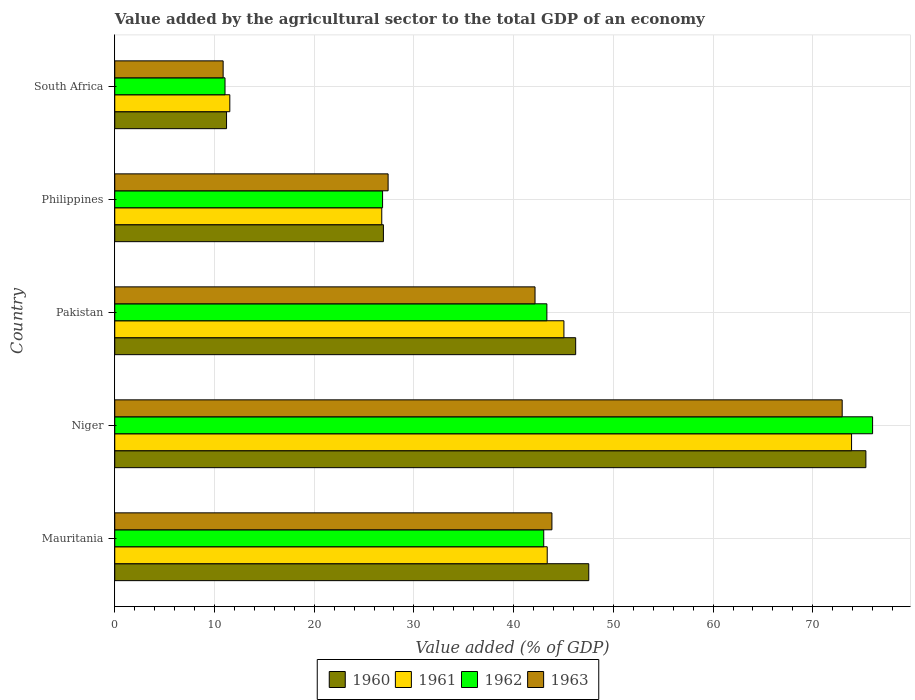How many groups of bars are there?
Keep it short and to the point. 5. Are the number of bars per tick equal to the number of legend labels?
Make the answer very short. Yes. Are the number of bars on each tick of the Y-axis equal?
Keep it short and to the point. Yes. How many bars are there on the 5th tick from the top?
Your response must be concise. 4. What is the label of the 1st group of bars from the top?
Your answer should be very brief. South Africa. What is the value added by the agricultural sector to the total GDP in 1963 in Niger?
Give a very brief answer. 72.95. Across all countries, what is the maximum value added by the agricultural sector to the total GDP in 1962?
Your response must be concise. 76. Across all countries, what is the minimum value added by the agricultural sector to the total GDP in 1963?
Your response must be concise. 10.87. In which country was the value added by the agricultural sector to the total GDP in 1962 maximum?
Offer a very short reply. Niger. In which country was the value added by the agricultural sector to the total GDP in 1961 minimum?
Provide a short and direct response. South Africa. What is the total value added by the agricultural sector to the total GDP in 1961 in the graph?
Offer a very short reply. 200.61. What is the difference between the value added by the agricultural sector to the total GDP in 1961 in Mauritania and that in Pakistan?
Offer a terse response. -1.68. What is the difference between the value added by the agricultural sector to the total GDP in 1961 in South Africa and the value added by the agricultural sector to the total GDP in 1960 in Pakistan?
Offer a very short reply. -34.68. What is the average value added by the agricultural sector to the total GDP in 1962 per country?
Your response must be concise. 40.05. What is the difference between the value added by the agricultural sector to the total GDP in 1962 and value added by the agricultural sector to the total GDP in 1960 in Niger?
Ensure brevity in your answer.  0.67. What is the ratio of the value added by the agricultural sector to the total GDP in 1962 in Mauritania to that in Pakistan?
Offer a terse response. 0.99. Is the difference between the value added by the agricultural sector to the total GDP in 1962 in Mauritania and South Africa greater than the difference between the value added by the agricultural sector to the total GDP in 1960 in Mauritania and South Africa?
Offer a very short reply. No. What is the difference between the highest and the second highest value added by the agricultural sector to the total GDP in 1962?
Offer a very short reply. 32.66. What is the difference between the highest and the lowest value added by the agricultural sector to the total GDP in 1961?
Make the answer very short. 62.35. Is the sum of the value added by the agricultural sector to the total GDP in 1961 in Philippines and South Africa greater than the maximum value added by the agricultural sector to the total GDP in 1963 across all countries?
Make the answer very short. No. Is it the case that in every country, the sum of the value added by the agricultural sector to the total GDP in 1961 and value added by the agricultural sector to the total GDP in 1962 is greater than the sum of value added by the agricultural sector to the total GDP in 1963 and value added by the agricultural sector to the total GDP in 1960?
Offer a very short reply. No. What does the 2nd bar from the top in Pakistan represents?
Your answer should be compact. 1962. What does the 4th bar from the bottom in Pakistan represents?
Your answer should be compact. 1963. Are all the bars in the graph horizontal?
Your answer should be compact. Yes. What is the difference between two consecutive major ticks on the X-axis?
Ensure brevity in your answer.  10. Where does the legend appear in the graph?
Provide a short and direct response. Bottom center. How many legend labels are there?
Ensure brevity in your answer.  4. What is the title of the graph?
Ensure brevity in your answer.  Value added by the agricultural sector to the total GDP of an economy. Does "1963" appear as one of the legend labels in the graph?
Your answer should be compact. Yes. What is the label or title of the X-axis?
Your answer should be compact. Value added (% of GDP). What is the Value added (% of GDP) in 1960 in Mauritania?
Offer a terse response. 47.53. What is the Value added (% of GDP) in 1961 in Mauritania?
Give a very brief answer. 43.37. What is the Value added (% of GDP) of 1962 in Mauritania?
Provide a succinct answer. 43.02. What is the Value added (% of GDP) of 1963 in Mauritania?
Your answer should be compact. 43.84. What is the Value added (% of GDP) of 1960 in Niger?
Your response must be concise. 75.32. What is the Value added (% of GDP) in 1961 in Niger?
Keep it short and to the point. 73.89. What is the Value added (% of GDP) in 1962 in Niger?
Make the answer very short. 76. What is the Value added (% of GDP) of 1963 in Niger?
Offer a terse response. 72.95. What is the Value added (% of GDP) of 1960 in Pakistan?
Offer a terse response. 46.22. What is the Value added (% of GDP) in 1961 in Pakistan?
Give a very brief answer. 45.04. What is the Value added (% of GDP) in 1962 in Pakistan?
Make the answer very short. 43.33. What is the Value added (% of GDP) in 1963 in Pakistan?
Your answer should be compact. 42.15. What is the Value added (% of GDP) in 1960 in Philippines?
Ensure brevity in your answer.  26.94. What is the Value added (% of GDP) of 1961 in Philippines?
Ensure brevity in your answer.  26.78. What is the Value added (% of GDP) in 1962 in Philippines?
Keep it short and to the point. 26.86. What is the Value added (% of GDP) of 1963 in Philippines?
Offer a very short reply. 27.41. What is the Value added (% of GDP) of 1960 in South Africa?
Ensure brevity in your answer.  11.21. What is the Value added (% of GDP) of 1961 in South Africa?
Offer a terse response. 11.54. What is the Value added (% of GDP) in 1962 in South Africa?
Your answer should be compact. 11.06. What is the Value added (% of GDP) of 1963 in South Africa?
Offer a very short reply. 10.87. Across all countries, what is the maximum Value added (% of GDP) in 1960?
Your response must be concise. 75.32. Across all countries, what is the maximum Value added (% of GDP) of 1961?
Keep it short and to the point. 73.89. Across all countries, what is the maximum Value added (% of GDP) in 1962?
Ensure brevity in your answer.  76. Across all countries, what is the maximum Value added (% of GDP) in 1963?
Make the answer very short. 72.95. Across all countries, what is the minimum Value added (% of GDP) in 1960?
Ensure brevity in your answer.  11.21. Across all countries, what is the minimum Value added (% of GDP) of 1961?
Make the answer very short. 11.54. Across all countries, what is the minimum Value added (% of GDP) of 1962?
Provide a succinct answer. 11.06. Across all countries, what is the minimum Value added (% of GDP) of 1963?
Your answer should be very brief. 10.87. What is the total Value added (% of GDP) in 1960 in the graph?
Give a very brief answer. 207.23. What is the total Value added (% of GDP) of 1961 in the graph?
Give a very brief answer. 200.61. What is the total Value added (% of GDP) of 1962 in the graph?
Offer a very short reply. 200.26. What is the total Value added (% of GDP) in 1963 in the graph?
Provide a succinct answer. 197.22. What is the difference between the Value added (% of GDP) in 1960 in Mauritania and that in Niger?
Ensure brevity in your answer.  -27.79. What is the difference between the Value added (% of GDP) in 1961 in Mauritania and that in Niger?
Your response must be concise. -30.52. What is the difference between the Value added (% of GDP) of 1962 in Mauritania and that in Niger?
Provide a succinct answer. -32.98. What is the difference between the Value added (% of GDP) of 1963 in Mauritania and that in Niger?
Give a very brief answer. -29.11. What is the difference between the Value added (% of GDP) in 1960 in Mauritania and that in Pakistan?
Provide a short and direct response. 1.31. What is the difference between the Value added (% of GDP) of 1961 in Mauritania and that in Pakistan?
Keep it short and to the point. -1.68. What is the difference between the Value added (% of GDP) of 1962 in Mauritania and that in Pakistan?
Provide a succinct answer. -0.31. What is the difference between the Value added (% of GDP) in 1963 in Mauritania and that in Pakistan?
Offer a terse response. 1.69. What is the difference between the Value added (% of GDP) in 1960 in Mauritania and that in Philippines?
Offer a terse response. 20.59. What is the difference between the Value added (% of GDP) of 1961 in Mauritania and that in Philippines?
Offer a very short reply. 16.59. What is the difference between the Value added (% of GDP) in 1962 in Mauritania and that in Philippines?
Offer a terse response. 16.16. What is the difference between the Value added (% of GDP) in 1963 in Mauritania and that in Philippines?
Your response must be concise. 16.43. What is the difference between the Value added (% of GDP) of 1960 in Mauritania and that in South Africa?
Your answer should be compact. 36.32. What is the difference between the Value added (% of GDP) of 1961 in Mauritania and that in South Africa?
Keep it short and to the point. 31.83. What is the difference between the Value added (% of GDP) of 1962 in Mauritania and that in South Africa?
Offer a terse response. 31.96. What is the difference between the Value added (% of GDP) of 1963 in Mauritania and that in South Africa?
Give a very brief answer. 32.97. What is the difference between the Value added (% of GDP) in 1960 in Niger and that in Pakistan?
Your answer should be very brief. 29.1. What is the difference between the Value added (% of GDP) in 1961 in Niger and that in Pakistan?
Provide a short and direct response. 28.84. What is the difference between the Value added (% of GDP) of 1962 in Niger and that in Pakistan?
Offer a terse response. 32.66. What is the difference between the Value added (% of GDP) of 1963 in Niger and that in Pakistan?
Your answer should be very brief. 30.8. What is the difference between the Value added (% of GDP) in 1960 in Niger and that in Philippines?
Give a very brief answer. 48.38. What is the difference between the Value added (% of GDP) in 1961 in Niger and that in Philippines?
Provide a short and direct response. 47.11. What is the difference between the Value added (% of GDP) in 1962 in Niger and that in Philippines?
Keep it short and to the point. 49.14. What is the difference between the Value added (% of GDP) of 1963 in Niger and that in Philippines?
Make the answer very short. 45.54. What is the difference between the Value added (% of GDP) in 1960 in Niger and that in South Africa?
Give a very brief answer. 64.11. What is the difference between the Value added (% of GDP) of 1961 in Niger and that in South Africa?
Offer a terse response. 62.35. What is the difference between the Value added (% of GDP) of 1962 in Niger and that in South Africa?
Make the answer very short. 64.94. What is the difference between the Value added (% of GDP) of 1963 in Niger and that in South Africa?
Make the answer very short. 62.08. What is the difference between the Value added (% of GDP) of 1960 in Pakistan and that in Philippines?
Offer a very short reply. 19.28. What is the difference between the Value added (% of GDP) of 1961 in Pakistan and that in Philippines?
Offer a very short reply. 18.27. What is the difference between the Value added (% of GDP) of 1962 in Pakistan and that in Philippines?
Provide a short and direct response. 16.48. What is the difference between the Value added (% of GDP) in 1963 in Pakistan and that in Philippines?
Your answer should be compact. 14.73. What is the difference between the Value added (% of GDP) in 1960 in Pakistan and that in South Africa?
Make the answer very short. 35.01. What is the difference between the Value added (% of GDP) in 1961 in Pakistan and that in South Africa?
Give a very brief answer. 33.51. What is the difference between the Value added (% of GDP) of 1962 in Pakistan and that in South Africa?
Offer a terse response. 32.28. What is the difference between the Value added (% of GDP) in 1963 in Pakistan and that in South Africa?
Your response must be concise. 31.28. What is the difference between the Value added (% of GDP) in 1960 in Philippines and that in South Africa?
Your response must be concise. 15.73. What is the difference between the Value added (% of GDP) of 1961 in Philippines and that in South Africa?
Your response must be concise. 15.24. What is the difference between the Value added (% of GDP) of 1962 in Philippines and that in South Africa?
Your response must be concise. 15.8. What is the difference between the Value added (% of GDP) in 1963 in Philippines and that in South Africa?
Give a very brief answer. 16.54. What is the difference between the Value added (% of GDP) of 1960 in Mauritania and the Value added (% of GDP) of 1961 in Niger?
Offer a very short reply. -26.35. What is the difference between the Value added (% of GDP) in 1960 in Mauritania and the Value added (% of GDP) in 1962 in Niger?
Ensure brevity in your answer.  -28.46. What is the difference between the Value added (% of GDP) of 1960 in Mauritania and the Value added (% of GDP) of 1963 in Niger?
Provide a succinct answer. -25.41. What is the difference between the Value added (% of GDP) in 1961 in Mauritania and the Value added (% of GDP) in 1962 in Niger?
Your response must be concise. -32.63. What is the difference between the Value added (% of GDP) in 1961 in Mauritania and the Value added (% of GDP) in 1963 in Niger?
Offer a very short reply. -29.58. What is the difference between the Value added (% of GDP) of 1962 in Mauritania and the Value added (% of GDP) of 1963 in Niger?
Offer a terse response. -29.93. What is the difference between the Value added (% of GDP) of 1960 in Mauritania and the Value added (% of GDP) of 1961 in Pakistan?
Provide a short and direct response. 2.49. What is the difference between the Value added (% of GDP) of 1960 in Mauritania and the Value added (% of GDP) of 1962 in Pakistan?
Give a very brief answer. 4.2. What is the difference between the Value added (% of GDP) of 1960 in Mauritania and the Value added (% of GDP) of 1963 in Pakistan?
Your answer should be compact. 5.39. What is the difference between the Value added (% of GDP) of 1961 in Mauritania and the Value added (% of GDP) of 1962 in Pakistan?
Offer a terse response. 0.03. What is the difference between the Value added (% of GDP) in 1961 in Mauritania and the Value added (% of GDP) in 1963 in Pakistan?
Your response must be concise. 1.22. What is the difference between the Value added (% of GDP) of 1962 in Mauritania and the Value added (% of GDP) of 1963 in Pakistan?
Make the answer very short. 0.87. What is the difference between the Value added (% of GDP) of 1960 in Mauritania and the Value added (% of GDP) of 1961 in Philippines?
Keep it short and to the point. 20.76. What is the difference between the Value added (% of GDP) of 1960 in Mauritania and the Value added (% of GDP) of 1962 in Philippines?
Keep it short and to the point. 20.68. What is the difference between the Value added (% of GDP) of 1960 in Mauritania and the Value added (% of GDP) of 1963 in Philippines?
Keep it short and to the point. 20.12. What is the difference between the Value added (% of GDP) of 1961 in Mauritania and the Value added (% of GDP) of 1962 in Philippines?
Your answer should be very brief. 16.51. What is the difference between the Value added (% of GDP) in 1961 in Mauritania and the Value added (% of GDP) in 1963 in Philippines?
Make the answer very short. 15.96. What is the difference between the Value added (% of GDP) in 1962 in Mauritania and the Value added (% of GDP) in 1963 in Philippines?
Offer a terse response. 15.61. What is the difference between the Value added (% of GDP) in 1960 in Mauritania and the Value added (% of GDP) in 1961 in South Africa?
Give a very brief answer. 36. What is the difference between the Value added (% of GDP) in 1960 in Mauritania and the Value added (% of GDP) in 1962 in South Africa?
Keep it short and to the point. 36.48. What is the difference between the Value added (% of GDP) in 1960 in Mauritania and the Value added (% of GDP) in 1963 in South Africa?
Offer a terse response. 36.67. What is the difference between the Value added (% of GDP) in 1961 in Mauritania and the Value added (% of GDP) in 1962 in South Africa?
Ensure brevity in your answer.  32.31. What is the difference between the Value added (% of GDP) of 1961 in Mauritania and the Value added (% of GDP) of 1963 in South Africa?
Offer a terse response. 32.5. What is the difference between the Value added (% of GDP) of 1962 in Mauritania and the Value added (% of GDP) of 1963 in South Africa?
Give a very brief answer. 32.15. What is the difference between the Value added (% of GDP) of 1960 in Niger and the Value added (% of GDP) of 1961 in Pakistan?
Offer a very short reply. 30.28. What is the difference between the Value added (% of GDP) of 1960 in Niger and the Value added (% of GDP) of 1962 in Pakistan?
Your answer should be very brief. 31.99. What is the difference between the Value added (% of GDP) of 1960 in Niger and the Value added (% of GDP) of 1963 in Pakistan?
Your answer should be compact. 33.18. What is the difference between the Value added (% of GDP) of 1961 in Niger and the Value added (% of GDP) of 1962 in Pakistan?
Offer a terse response. 30.55. What is the difference between the Value added (% of GDP) in 1961 in Niger and the Value added (% of GDP) in 1963 in Pakistan?
Your response must be concise. 31.74. What is the difference between the Value added (% of GDP) in 1962 in Niger and the Value added (% of GDP) in 1963 in Pakistan?
Ensure brevity in your answer.  33.85. What is the difference between the Value added (% of GDP) of 1960 in Niger and the Value added (% of GDP) of 1961 in Philippines?
Provide a short and direct response. 48.55. What is the difference between the Value added (% of GDP) in 1960 in Niger and the Value added (% of GDP) in 1962 in Philippines?
Give a very brief answer. 48.47. What is the difference between the Value added (% of GDP) of 1960 in Niger and the Value added (% of GDP) of 1963 in Philippines?
Provide a succinct answer. 47.91. What is the difference between the Value added (% of GDP) in 1961 in Niger and the Value added (% of GDP) in 1962 in Philippines?
Your response must be concise. 47.03. What is the difference between the Value added (% of GDP) of 1961 in Niger and the Value added (% of GDP) of 1963 in Philippines?
Provide a short and direct response. 46.48. What is the difference between the Value added (% of GDP) in 1962 in Niger and the Value added (% of GDP) in 1963 in Philippines?
Provide a succinct answer. 48.59. What is the difference between the Value added (% of GDP) of 1960 in Niger and the Value added (% of GDP) of 1961 in South Africa?
Ensure brevity in your answer.  63.79. What is the difference between the Value added (% of GDP) of 1960 in Niger and the Value added (% of GDP) of 1962 in South Africa?
Your response must be concise. 64.27. What is the difference between the Value added (% of GDP) of 1960 in Niger and the Value added (% of GDP) of 1963 in South Africa?
Offer a terse response. 64.46. What is the difference between the Value added (% of GDP) in 1961 in Niger and the Value added (% of GDP) in 1962 in South Africa?
Give a very brief answer. 62.83. What is the difference between the Value added (% of GDP) of 1961 in Niger and the Value added (% of GDP) of 1963 in South Africa?
Keep it short and to the point. 63.02. What is the difference between the Value added (% of GDP) in 1962 in Niger and the Value added (% of GDP) in 1963 in South Africa?
Your response must be concise. 65.13. What is the difference between the Value added (% of GDP) in 1960 in Pakistan and the Value added (% of GDP) in 1961 in Philippines?
Your answer should be compact. 19.44. What is the difference between the Value added (% of GDP) of 1960 in Pakistan and the Value added (% of GDP) of 1962 in Philippines?
Provide a short and direct response. 19.36. What is the difference between the Value added (% of GDP) of 1960 in Pakistan and the Value added (% of GDP) of 1963 in Philippines?
Keep it short and to the point. 18.81. What is the difference between the Value added (% of GDP) of 1961 in Pakistan and the Value added (% of GDP) of 1962 in Philippines?
Your answer should be very brief. 18.19. What is the difference between the Value added (% of GDP) of 1961 in Pakistan and the Value added (% of GDP) of 1963 in Philippines?
Ensure brevity in your answer.  17.63. What is the difference between the Value added (% of GDP) of 1962 in Pakistan and the Value added (% of GDP) of 1963 in Philippines?
Offer a very short reply. 15.92. What is the difference between the Value added (% of GDP) in 1960 in Pakistan and the Value added (% of GDP) in 1961 in South Africa?
Make the answer very short. 34.68. What is the difference between the Value added (% of GDP) in 1960 in Pakistan and the Value added (% of GDP) in 1962 in South Africa?
Make the answer very short. 35.16. What is the difference between the Value added (% of GDP) in 1960 in Pakistan and the Value added (% of GDP) in 1963 in South Africa?
Provide a short and direct response. 35.35. What is the difference between the Value added (% of GDP) in 1961 in Pakistan and the Value added (% of GDP) in 1962 in South Africa?
Provide a succinct answer. 33.99. What is the difference between the Value added (% of GDP) in 1961 in Pakistan and the Value added (% of GDP) in 1963 in South Africa?
Ensure brevity in your answer.  34.17. What is the difference between the Value added (% of GDP) in 1962 in Pakistan and the Value added (% of GDP) in 1963 in South Africa?
Ensure brevity in your answer.  32.46. What is the difference between the Value added (% of GDP) in 1960 in Philippines and the Value added (% of GDP) in 1961 in South Africa?
Ensure brevity in your answer.  15.4. What is the difference between the Value added (% of GDP) of 1960 in Philippines and the Value added (% of GDP) of 1962 in South Africa?
Your answer should be compact. 15.88. What is the difference between the Value added (% of GDP) in 1960 in Philippines and the Value added (% of GDP) in 1963 in South Africa?
Give a very brief answer. 16.07. What is the difference between the Value added (% of GDP) of 1961 in Philippines and the Value added (% of GDP) of 1962 in South Africa?
Offer a very short reply. 15.72. What is the difference between the Value added (% of GDP) of 1961 in Philippines and the Value added (% of GDP) of 1963 in South Africa?
Offer a very short reply. 15.91. What is the difference between the Value added (% of GDP) of 1962 in Philippines and the Value added (% of GDP) of 1963 in South Africa?
Keep it short and to the point. 15.99. What is the average Value added (% of GDP) of 1960 per country?
Give a very brief answer. 41.45. What is the average Value added (% of GDP) in 1961 per country?
Your response must be concise. 40.12. What is the average Value added (% of GDP) of 1962 per country?
Give a very brief answer. 40.05. What is the average Value added (% of GDP) of 1963 per country?
Ensure brevity in your answer.  39.44. What is the difference between the Value added (% of GDP) in 1960 and Value added (% of GDP) in 1961 in Mauritania?
Ensure brevity in your answer.  4.17. What is the difference between the Value added (% of GDP) in 1960 and Value added (% of GDP) in 1962 in Mauritania?
Offer a very short reply. 4.52. What is the difference between the Value added (% of GDP) of 1960 and Value added (% of GDP) of 1963 in Mauritania?
Your response must be concise. 3.69. What is the difference between the Value added (% of GDP) in 1961 and Value added (% of GDP) in 1962 in Mauritania?
Provide a succinct answer. 0.35. What is the difference between the Value added (% of GDP) of 1961 and Value added (% of GDP) of 1963 in Mauritania?
Offer a terse response. -0.47. What is the difference between the Value added (% of GDP) in 1962 and Value added (% of GDP) in 1963 in Mauritania?
Offer a very short reply. -0.82. What is the difference between the Value added (% of GDP) of 1960 and Value added (% of GDP) of 1961 in Niger?
Offer a very short reply. 1.44. What is the difference between the Value added (% of GDP) of 1960 and Value added (% of GDP) of 1962 in Niger?
Make the answer very short. -0.67. What is the difference between the Value added (% of GDP) of 1960 and Value added (% of GDP) of 1963 in Niger?
Your answer should be very brief. 2.38. What is the difference between the Value added (% of GDP) in 1961 and Value added (% of GDP) in 1962 in Niger?
Provide a succinct answer. -2.11. What is the difference between the Value added (% of GDP) in 1961 and Value added (% of GDP) in 1963 in Niger?
Provide a succinct answer. 0.94. What is the difference between the Value added (% of GDP) in 1962 and Value added (% of GDP) in 1963 in Niger?
Provide a succinct answer. 3.05. What is the difference between the Value added (% of GDP) in 1960 and Value added (% of GDP) in 1961 in Pakistan?
Your response must be concise. 1.18. What is the difference between the Value added (% of GDP) in 1960 and Value added (% of GDP) in 1962 in Pakistan?
Offer a very short reply. 2.89. What is the difference between the Value added (% of GDP) in 1960 and Value added (% of GDP) in 1963 in Pakistan?
Ensure brevity in your answer.  4.07. What is the difference between the Value added (% of GDP) of 1961 and Value added (% of GDP) of 1962 in Pakistan?
Make the answer very short. 1.71. What is the difference between the Value added (% of GDP) of 1961 and Value added (% of GDP) of 1963 in Pakistan?
Your answer should be very brief. 2.9. What is the difference between the Value added (% of GDP) in 1962 and Value added (% of GDP) in 1963 in Pakistan?
Ensure brevity in your answer.  1.19. What is the difference between the Value added (% of GDP) in 1960 and Value added (% of GDP) in 1961 in Philippines?
Provide a short and direct response. 0.16. What is the difference between the Value added (% of GDP) of 1960 and Value added (% of GDP) of 1962 in Philippines?
Offer a terse response. 0.08. What is the difference between the Value added (% of GDP) of 1960 and Value added (% of GDP) of 1963 in Philippines?
Keep it short and to the point. -0.47. What is the difference between the Value added (% of GDP) in 1961 and Value added (% of GDP) in 1962 in Philippines?
Give a very brief answer. -0.08. What is the difference between the Value added (% of GDP) in 1961 and Value added (% of GDP) in 1963 in Philippines?
Your response must be concise. -0.64. What is the difference between the Value added (% of GDP) of 1962 and Value added (% of GDP) of 1963 in Philippines?
Your answer should be very brief. -0.55. What is the difference between the Value added (% of GDP) in 1960 and Value added (% of GDP) in 1961 in South Africa?
Your response must be concise. -0.33. What is the difference between the Value added (% of GDP) of 1960 and Value added (% of GDP) of 1962 in South Africa?
Your answer should be compact. 0.15. What is the difference between the Value added (% of GDP) in 1960 and Value added (% of GDP) in 1963 in South Africa?
Keep it short and to the point. 0.34. What is the difference between the Value added (% of GDP) of 1961 and Value added (% of GDP) of 1962 in South Africa?
Make the answer very short. 0.48. What is the difference between the Value added (% of GDP) in 1961 and Value added (% of GDP) in 1963 in South Africa?
Offer a very short reply. 0.67. What is the difference between the Value added (% of GDP) in 1962 and Value added (% of GDP) in 1963 in South Africa?
Ensure brevity in your answer.  0.19. What is the ratio of the Value added (% of GDP) of 1960 in Mauritania to that in Niger?
Your response must be concise. 0.63. What is the ratio of the Value added (% of GDP) in 1961 in Mauritania to that in Niger?
Offer a terse response. 0.59. What is the ratio of the Value added (% of GDP) of 1962 in Mauritania to that in Niger?
Keep it short and to the point. 0.57. What is the ratio of the Value added (% of GDP) of 1963 in Mauritania to that in Niger?
Ensure brevity in your answer.  0.6. What is the ratio of the Value added (% of GDP) in 1960 in Mauritania to that in Pakistan?
Provide a short and direct response. 1.03. What is the ratio of the Value added (% of GDP) in 1961 in Mauritania to that in Pakistan?
Offer a very short reply. 0.96. What is the ratio of the Value added (% of GDP) in 1963 in Mauritania to that in Pakistan?
Provide a short and direct response. 1.04. What is the ratio of the Value added (% of GDP) in 1960 in Mauritania to that in Philippines?
Offer a very short reply. 1.76. What is the ratio of the Value added (% of GDP) in 1961 in Mauritania to that in Philippines?
Ensure brevity in your answer.  1.62. What is the ratio of the Value added (% of GDP) of 1962 in Mauritania to that in Philippines?
Give a very brief answer. 1.6. What is the ratio of the Value added (% of GDP) in 1963 in Mauritania to that in Philippines?
Make the answer very short. 1.6. What is the ratio of the Value added (% of GDP) of 1960 in Mauritania to that in South Africa?
Your answer should be compact. 4.24. What is the ratio of the Value added (% of GDP) in 1961 in Mauritania to that in South Africa?
Ensure brevity in your answer.  3.76. What is the ratio of the Value added (% of GDP) in 1962 in Mauritania to that in South Africa?
Your response must be concise. 3.89. What is the ratio of the Value added (% of GDP) of 1963 in Mauritania to that in South Africa?
Ensure brevity in your answer.  4.03. What is the ratio of the Value added (% of GDP) of 1960 in Niger to that in Pakistan?
Offer a very short reply. 1.63. What is the ratio of the Value added (% of GDP) in 1961 in Niger to that in Pakistan?
Keep it short and to the point. 1.64. What is the ratio of the Value added (% of GDP) of 1962 in Niger to that in Pakistan?
Your response must be concise. 1.75. What is the ratio of the Value added (% of GDP) in 1963 in Niger to that in Pakistan?
Your answer should be compact. 1.73. What is the ratio of the Value added (% of GDP) of 1960 in Niger to that in Philippines?
Provide a succinct answer. 2.8. What is the ratio of the Value added (% of GDP) in 1961 in Niger to that in Philippines?
Make the answer very short. 2.76. What is the ratio of the Value added (% of GDP) of 1962 in Niger to that in Philippines?
Your response must be concise. 2.83. What is the ratio of the Value added (% of GDP) of 1963 in Niger to that in Philippines?
Your answer should be compact. 2.66. What is the ratio of the Value added (% of GDP) of 1960 in Niger to that in South Africa?
Your answer should be compact. 6.72. What is the ratio of the Value added (% of GDP) of 1961 in Niger to that in South Africa?
Ensure brevity in your answer.  6.4. What is the ratio of the Value added (% of GDP) in 1962 in Niger to that in South Africa?
Ensure brevity in your answer.  6.87. What is the ratio of the Value added (% of GDP) in 1963 in Niger to that in South Africa?
Ensure brevity in your answer.  6.71. What is the ratio of the Value added (% of GDP) in 1960 in Pakistan to that in Philippines?
Give a very brief answer. 1.72. What is the ratio of the Value added (% of GDP) in 1961 in Pakistan to that in Philippines?
Ensure brevity in your answer.  1.68. What is the ratio of the Value added (% of GDP) in 1962 in Pakistan to that in Philippines?
Your response must be concise. 1.61. What is the ratio of the Value added (% of GDP) in 1963 in Pakistan to that in Philippines?
Give a very brief answer. 1.54. What is the ratio of the Value added (% of GDP) in 1960 in Pakistan to that in South Africa?
Offer a terse response. 4.12. What is the ratio of the Value added (% of GDP) in 1961 in Pakistan to that in South Africa?
Provide a short and direct response. 3.9. What is the ratio of the Value added (% of GDP) in 1962 in Pakistan to that in South Africa?
Your response must be concise. 3.92. What is the ratio of the Value added (% of GDP) of 1963 in Pakistan to that in South Africa?
Your response must be concise. 3.88. What is the ratio of the Value added (% of GDP) of 1960 in Philippines to that in South Africa?
Your answer should be very brief. 2.4. What is the ratio of the Value added (% of GDP) in 1961 in Philippines to that in South Africa?
Your response must be concise. 2.32. What is the ratio of the Value added (% of GDP) in 1962 in Philippines to that in South Africa?
Your response must be concise. 2.43. What is the ratio of the Value added (% of GDP) in 1963 in Philippines to that in South Africa?
Offer a very short reply. 2.52. What is the difference between the highest and the second highest Value added (% of GDP) of 1960?
Make the answer very short. 27.79. What is the difference between the highest and the second highest Value added (% of GDP) in 1961?
Offer a terse response. 28.84. What is the difference between the highest and the second highest Value added (% of GDP) in 1962?
Provide a succinct answer. 32.66. What is the difference between the highest and the second highest Value added (% of GDP) in 1963?
Ensure brevity in your answer.  29.11. What is the difference between the highest and the lowest Value added (% of GDP) of 1960?
Make the answer very short. 64.11. What is the difference between the highest and the lowest Value added (% of GDP) of 1961?
Provide a short and direct response. 62.35. What is the difference between the highest and the lowest Value added (% of GDP) of 1962?
Your answer should be very brief. 64.94. What is the difference between the highest and the lowest Value added (% of GDP) of 1963?
Keep it short and to the point. 62.08. 